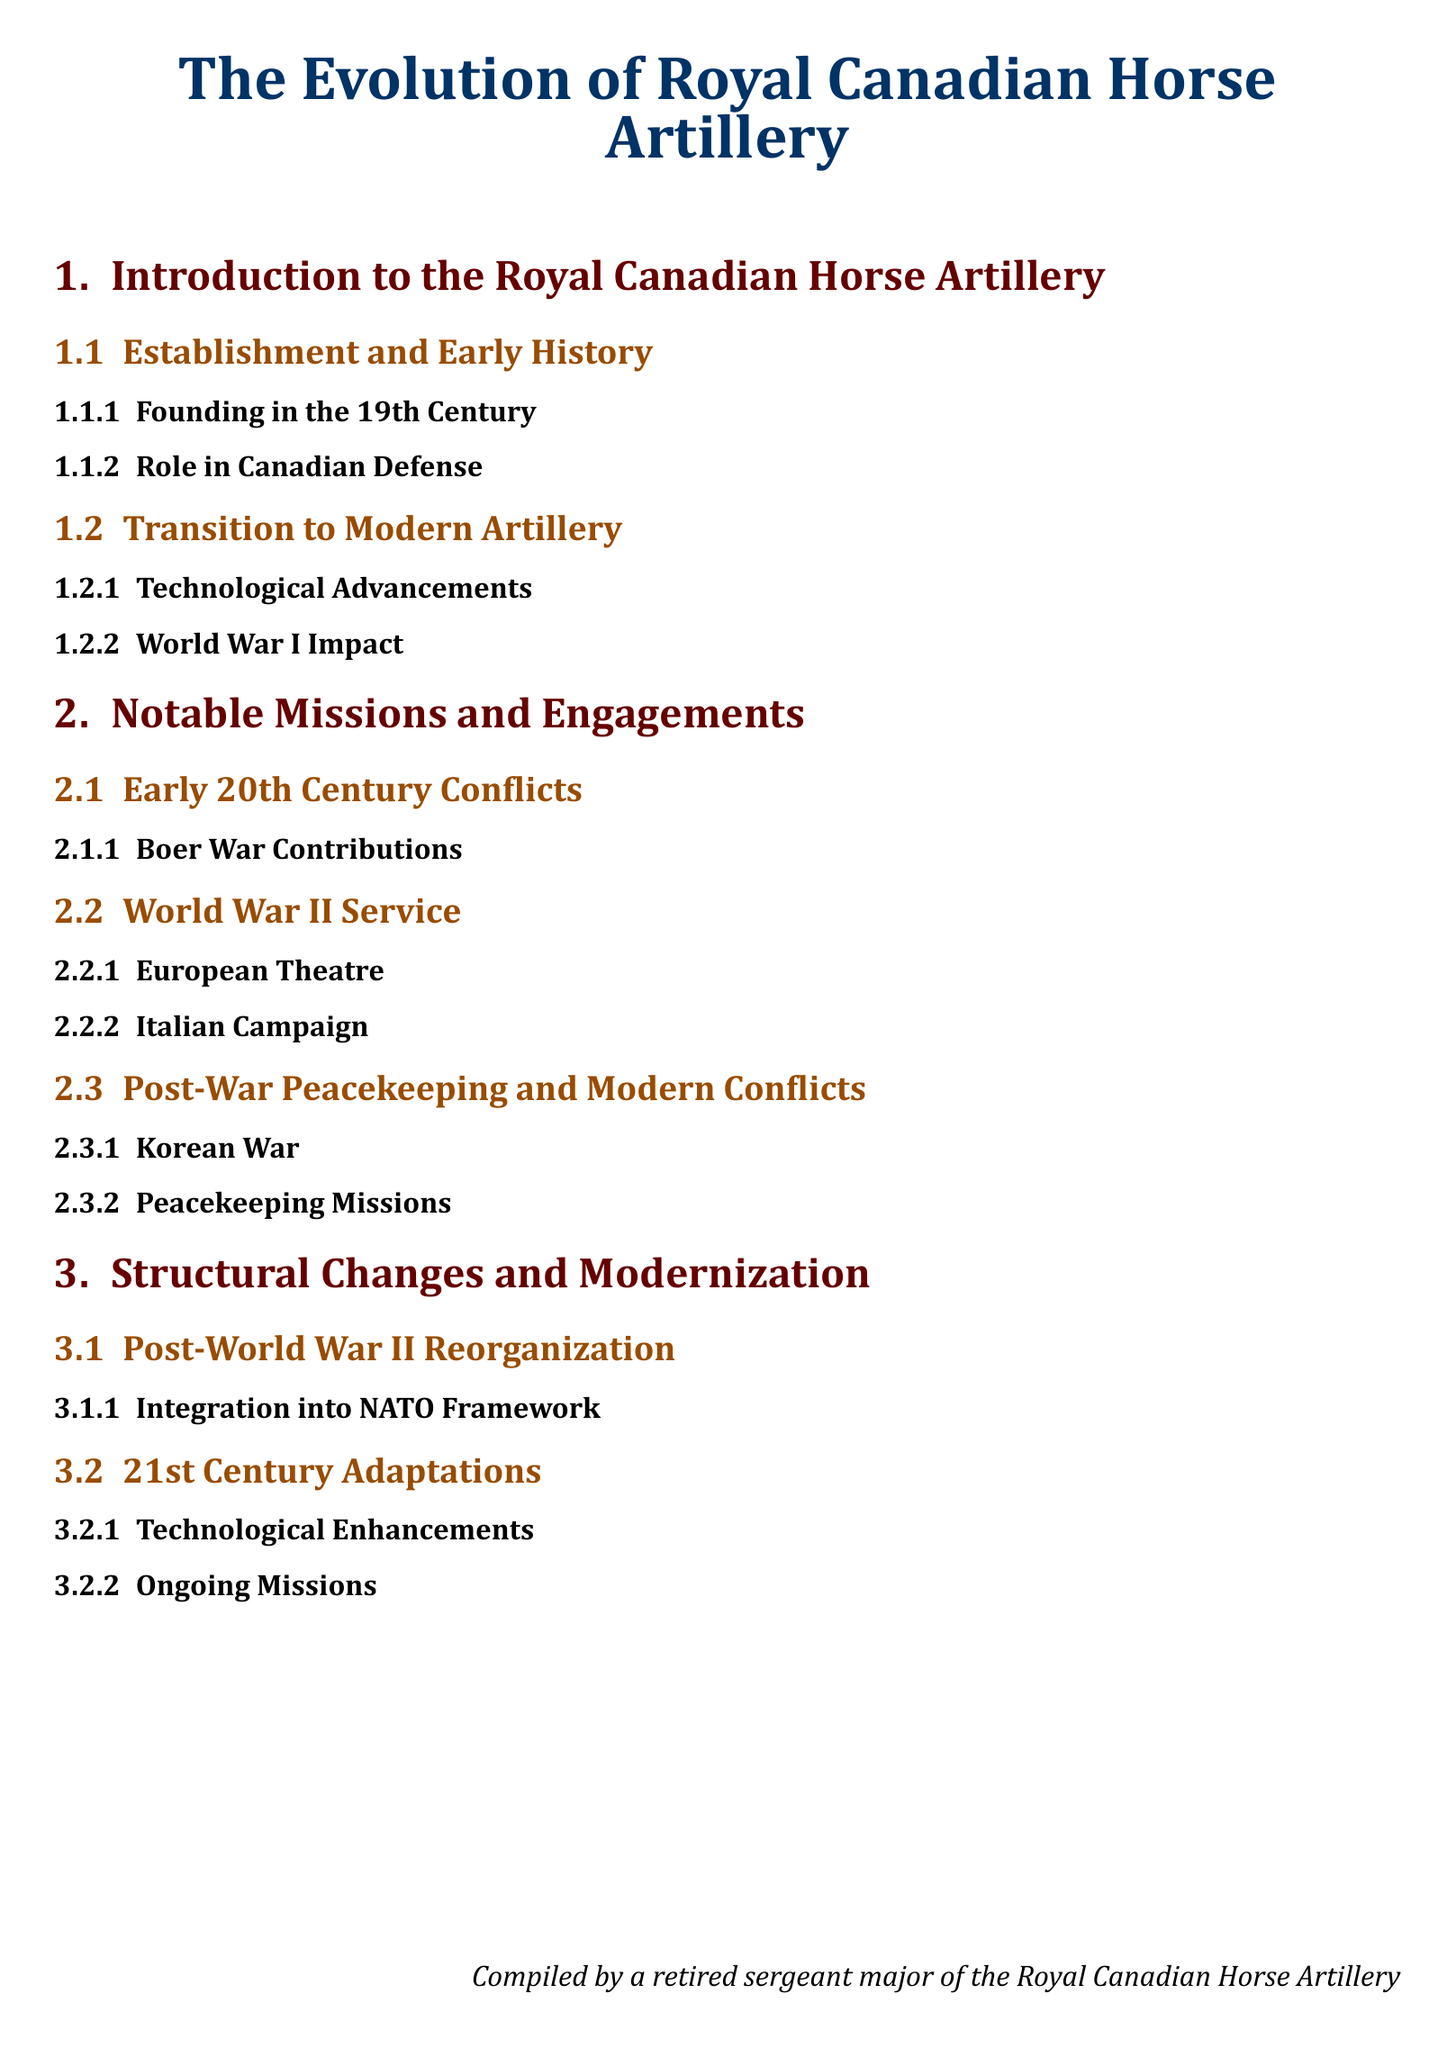what century was the Royal Canadian Horse Artillery founded? The establishment of the Royal Canadian Horse Artillery occurred in the 19th century, as mentioned in the document.
Answer: 19th Century Which global conflict significantly impacted the Royal Canadian Horse Artillery's transition to modern artillery? The document states that World War I had a noteworthy impact on the transition to modern artillery.
Answer: World War I Name one of the notable missions of the Royal Canadian Horse Artillery during World War II. The document lists several notable missions, including the engagements in the European Theatre and the Italian Campaign during World War II.
Answer: European Theatre What was a contribution of the Royal Canadian Horse Artillery in the early 20th century? The document specifies the contributions made by the Royal Canadian Horse Artillery during the Boer War as part of their early 20th century engagements.
Answer: Boer War Contributions What framework did the Royal Canadian Horse Artillery integrate into after World War II? The document states that after World War II, there was a reorganization which included integration into the NATO framework.
Answer: NATO Framework What type of missions did the Royal Canadian Horse Artillery participate in post-war? In the document, post-war activities included peacekeeping missions that the Royal Canadian Horse Artillery was involved in.
Answer: Peacekeeping Missions What is one of the 21st-century adaptations of the Royal Canadian Horse Artillery? Technological enhancements are listed in the document as a notable adaptation in the 21st century for the Royal Canadian Horse Artillery.
Answer: Technological Enhancements Who compiled the document? The document includes a statement indicating that it was compiled by a retired sergeant major of the Royal Canadian Horse Artillery.
Answer: Retired Sergeant Major 